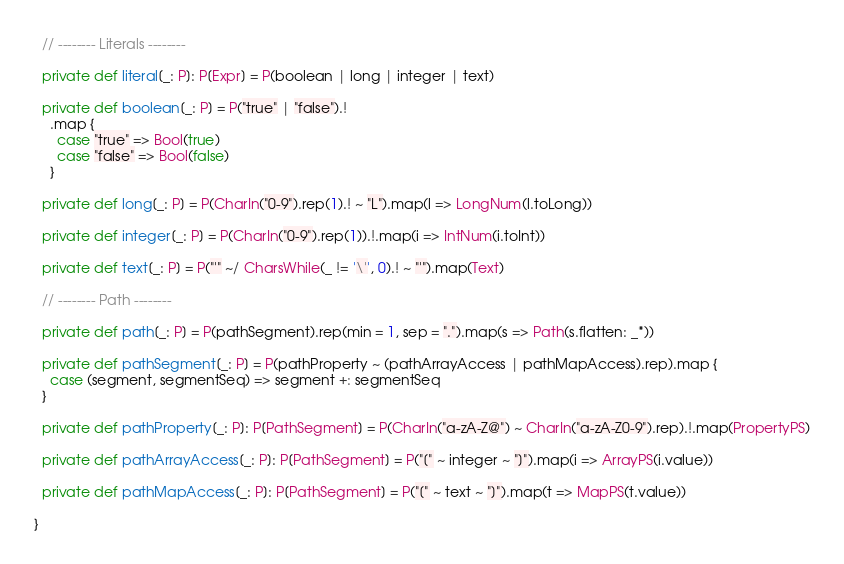<code> <loc_0><loc_0><loc_500><loc_500><_Scala_>  // -------- Literals --------

  private def literal[_: P]: P[Expr] = P(boolean | long | integer | text)

  private def boolean[_: P] = P("true" | "false").!
    .map {
      case "true" => Bool(true)
      case "false" => Bool(false)
    }

  private def long[_: P] = P(CharIn("0-9").rep(1).! ~ "L").map(l => LongNum(l.toLong))

  private def integer[_: P] = P(CharIn("0-9").rep(1)).!.map(i => IntNum(i.toInt))

  private def text[_: P] = P("'" ~/ CharsWhile(_ != '\'', 0).! ~ "'").map(Text)

  // -------- Path --------

  private def path[_: P] = P(pathSegment).rep(min = 1, sep = ".").map(s => Path(s.flatten: _*))

  private def pathSegment[_: P] = P(pathProperty ~ (pathArrayAccess | pathMapAccess).rep).map {
    case (segment, segmentSeq) => segment +: segmentSeq
  }

  private def pathProperty[_: P]: P[PathSegment] = P(CharIn("a-zA-Z@") ~ CharIn("a-zA-Z0-9").rep).!.map(PropertyPS)

  private def pathArrayAccess[_: P]: P[PathSegment] = P("[" ~ integer ~ "]").map(i => ArrayPS(i.value))

  private def pathMapAccess[_: P]: P[PathSegment] = P("[" ~ text ~ "]").map(t => MapPS(t.value))

}
</code> 